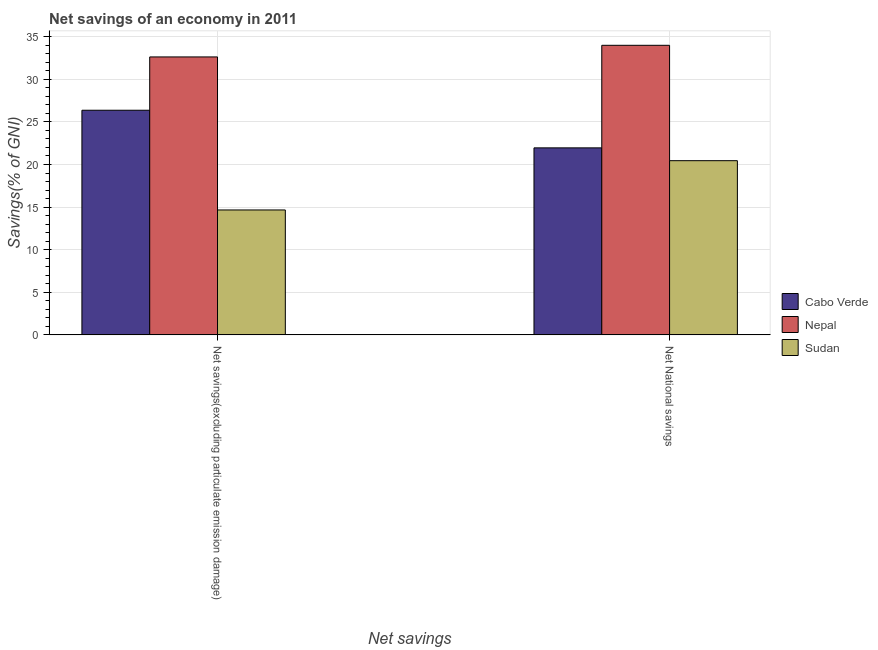How many different coloured bars are there?
Keep it short and to the point. 3. How many groups of bars are there?
Offer a very short reply. 2. Are the number of bars per tick equal to the number of legend labels?
Give a very brief answer. Yes. Are the number of bars on each tick of the X-axis equal?
Offer a terse response. Yes. How many bars are there on the 2nd tick from the left?
Your response must be concise. 3. How many bars are there on the 1st tick from the right?
Offer a terse response. 3. What is the label of the 1st group of bars from the left?
Your answer should be compact. Net savings(excluding particulate emission damage). What is the net national savings in Cabo Verde?
Offer a terse response. 21.95. Across all countries, what is the maximum net national savings?
Ensure brevity in your answer.  33.99. Across all countries, what is the minimum net savings(excluding particulate emission damage)?
Keep it short and to the point. 14.66. In which country was the net national savings maximum?
Make the answer very short. Nepal. In which country was the net national savings minimum?
Your answer should be compact. Sudan. What is the total net national savings in the graph?
Keep it short and to the point. 76.39. What is the difference between the net savings(excluding particulate emission damage) in Cabo Verde and that in Sudan?
Your response must be concise. 11.7. What is the difference between the net savings(excluding particulate emission damage) in Nepal and the net national savings in Cabo Verde?
Your response must be concise. 10.67. What is the average net savings(excluding particulate emission damage) per country?
Make the answer very short. 24.55. What is the difference between the net national savings and net savings(excluding particulate emission damage) in Cabo Verde?
Keep it short and to the point. -4.42. What is the ratio of the net savings(excluding particulate emission damage) in Sudan to that in Cabo Verde?
Keep it short and to the point. 0.56. In how many countries, is the net national savings greater than the average net national savings taken over all countries?
Your answer should be compact. 1. What does the 3rd bar from the left in Net savings(excluding particulate emission damage) represents?
Offer a very short reply. Sudan. What does the 3rd bar from the right in Net National savings represents?
Your answer should be very brief. Cabo Verde. How many bars are there?
Your answer should be compact. 6. Are all the bars in the graph horizontal?
Your response must be concise. No. What is the difference between two consecutive major ticks on the Y-axis?
Give a very brief answer. 5. Are the values on the major ticks of Y-axis written in scientific E-notation?
Your answer should be very brief. No. Does the graph contain any zero values?
Offer a terse response. No. Does the graph contain grids?
Your answer should be compact. Yes. How many legend labels are there?
Give a very brief answer. 3. How are the legend labels stacked?
Offer a terse response. Vertical. What is the title of the graph?
Your answer should be very brief. Net savings of an economy in 2011. What is the label or title of the X-axis?
Make the answer very short. Net savings. What is the label or title of the Y-axis?
Your answer should be very brief. Savings(% of GNI). What is the Savings(% of GNI) in Cabo Verde in Net savings(excluding particulate emission damage)?
Keep it short and to the point. 26.37. What is the Savings(% of GNI) of Nepal in Net savings(excluding particulate emission damage)?
Make the answer very short. 32.63. What is the Savings(% of GNI) in Sudan in Net savings(excluding particulate emission damage)?
Make the answer very short. 14.66. What is the Savings(% of GNI) in Cabo Verde in Net National savings?
Keep it short and to the point. 21.95. What is the Savings(% of GNI) of Nepal in Net National savings?
Make the answer very short. 33.99. What is the Savings(% of GNI) of Sudan in Net National savings?
Offer a very short reply. 20.45. Across all Net savings, what is the maximum Savings(% of GNI) in Cabo Verde?
Offer a very short reply. 26.37. Across all Net savings, what is the maximum Savings(% of GNI) of Nepal?
Ensure brevity in your answer.  33.99. Across all Net savings, what is the maximum Savings(% of GNI) of Sudan?
Give a very brief answer. 20.45. Across all Net savings, what is the minimum Savings(% of GNI) in Cabo Verde?
Offer a very short reply. 21.95. Across all Net savings, what is the minimum Savings(% of GNI) in Nepal?
Offer a terse response. 32.63. Across all Net savings, what is the minimum Savings(% of GNI) in Sudan?
Ensure brevity in your answer.  14.66. What is the total Savings(% of GNI) of Cabo Verde in the graph?
Offer a terse response. 48.32. What is the total Savings(% of GNI) in Nepal in the graph?
Ensure brevity in your answer.  66.62. What is the total Savings(% of GNI) of Sudan in the graph?
Your response must be concise. 35.11. What is the difference between the Savings(% of GNI) in Cabo Verde in Net savings(excluding particulate emission damage) and that in Net National savings?
Make the answer very short. 4.42. What is the difference between the Savings(% of GNI) of Nepal in Net savings(excluding particulate emission damage) and that in Net National savings?
Your response must be concise. -1.36. What is the difference between the Savings(% of GNI) of Sudan in Net savings(excluding particulate emission damage) and that in Net National savings?
Your response must be concise. -5.78. What is the difference between the Savings(% of GNI) in Cabo Verde in Net savings(excluding particulate emission damage) and the Savings(% of GNI) in Nepal in Net National savings?
Provide a succinct answer. -7.62. What is the difference between the Savings(% of GNI) of Cabo Verde in Net savings(excluding particulate emission damage) and the Savings(% of GNI) of Sudan in Net National savings?
Your response must be concise. 5.92. What is the difference between the Savings(% of GNI) in Nepal in Net savings(excluding particulate emission damage) and the Savings(% of GNI) in Sudan in Net National savings?
Provide a succinct answer. 12.18. What is the average Savings(% of GNI) in Cabo Verde per Net savings?
Provide a succinct answer. 24.16. What is the average Savings(% of GNI) in Nepal per Net savings?
Give a very brief answer. 33.31. What is the average Savings(% of GNI) in Sudan per Net savings?
Your response must be concise. 17.56. What is the difference between the Savings(% of GNI) in Cabo Verde and Savings(% of GNI) in Nepal in Net savings(excluding particulate emission damage)?
Give a very brief answer. -6.26. What is the difference between the Savings(% of GNI) of Cabo Verde and Savings(% of GNI) of Sudan in Net savings(excluding particulate emission damage)?
Make the answer very short. 11.7. What is the difference between the Savings(% of GNI) in Nepal and Savings(% of GNI) in Sudan in Net savings(excluding particulate emission damage)?
Give a very brief answer. 17.96. What is the difference between the Savings(% of GNI) in Cabo Verde and Savings(% of GNI) in Nepal in Net National savings?
Make the answer very short. -12.04. What is the difference between the Savings(% of GNI) of Cabo Verde and Savings(% of GNI) of Sudan in Net National savings?
Your answer should be very brief. 1.5. What is the difference between the Savings(% of GNI) of Nepal and Savings(% of GNI) of Sudan in Net National savings?
Your answer should be very brief. 13.54. What is the ratio of the Savings(% of GNI) of Cabo Verde in Net savings(excluding particulate emission damage) to that in Net National savings?
Provide a succinct answer. 1.2. What is the ratio of the Savings(% of GNI) of Nepal in Net savings(excluding particulate emission damage) to that in Net National savings?
Ensure brevity in your answer.  0.96. What is the ratio of the Savings(% of GNI) of Sudan in Net savings(excluding particulate emission damage) to that in Net National savings?
Provide a succinct answer. 0.72. What is the difference between the highest and the second highest Savings(% of GNI) of Cabo Verde?
Make the answer very short. 4.42. What is the difference between the highest and the second highest Savings(% of GNI) in Nepal?
Offer a terse response. 1.36. What is the difference between the highest and the second highest Savings(% of GNI) in Sudan?
Keep it short and to the point. 5.78. What is the difference between the highest and the lowest Savings(% of GNI) of Cabo Verde?
Give a very brief answer. 4.42. What is the difference between the highest and the lowest Savings(% of GNI) in Nepal?
Your response must be concise. 1.36. What is the difference between the highest and the lowest Savings(% of GNI) of Sudan?
Ensure brevity in your answer.  5.78. 